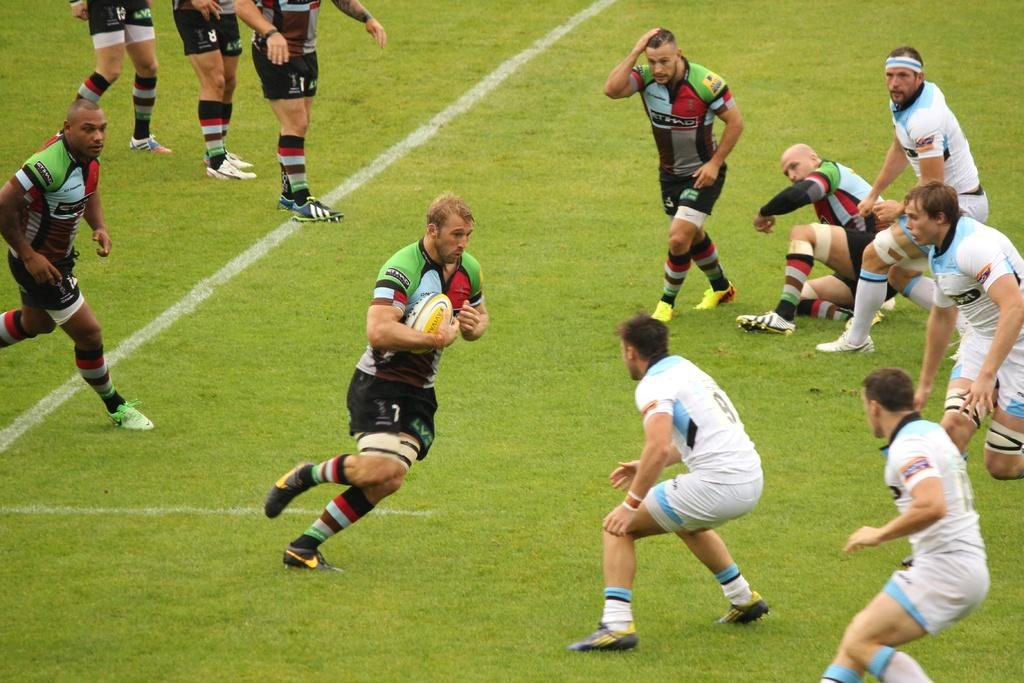<image>
Summarize the visual content of the image. A rugby game in which number 9 is defending from a player on the opposing team. 